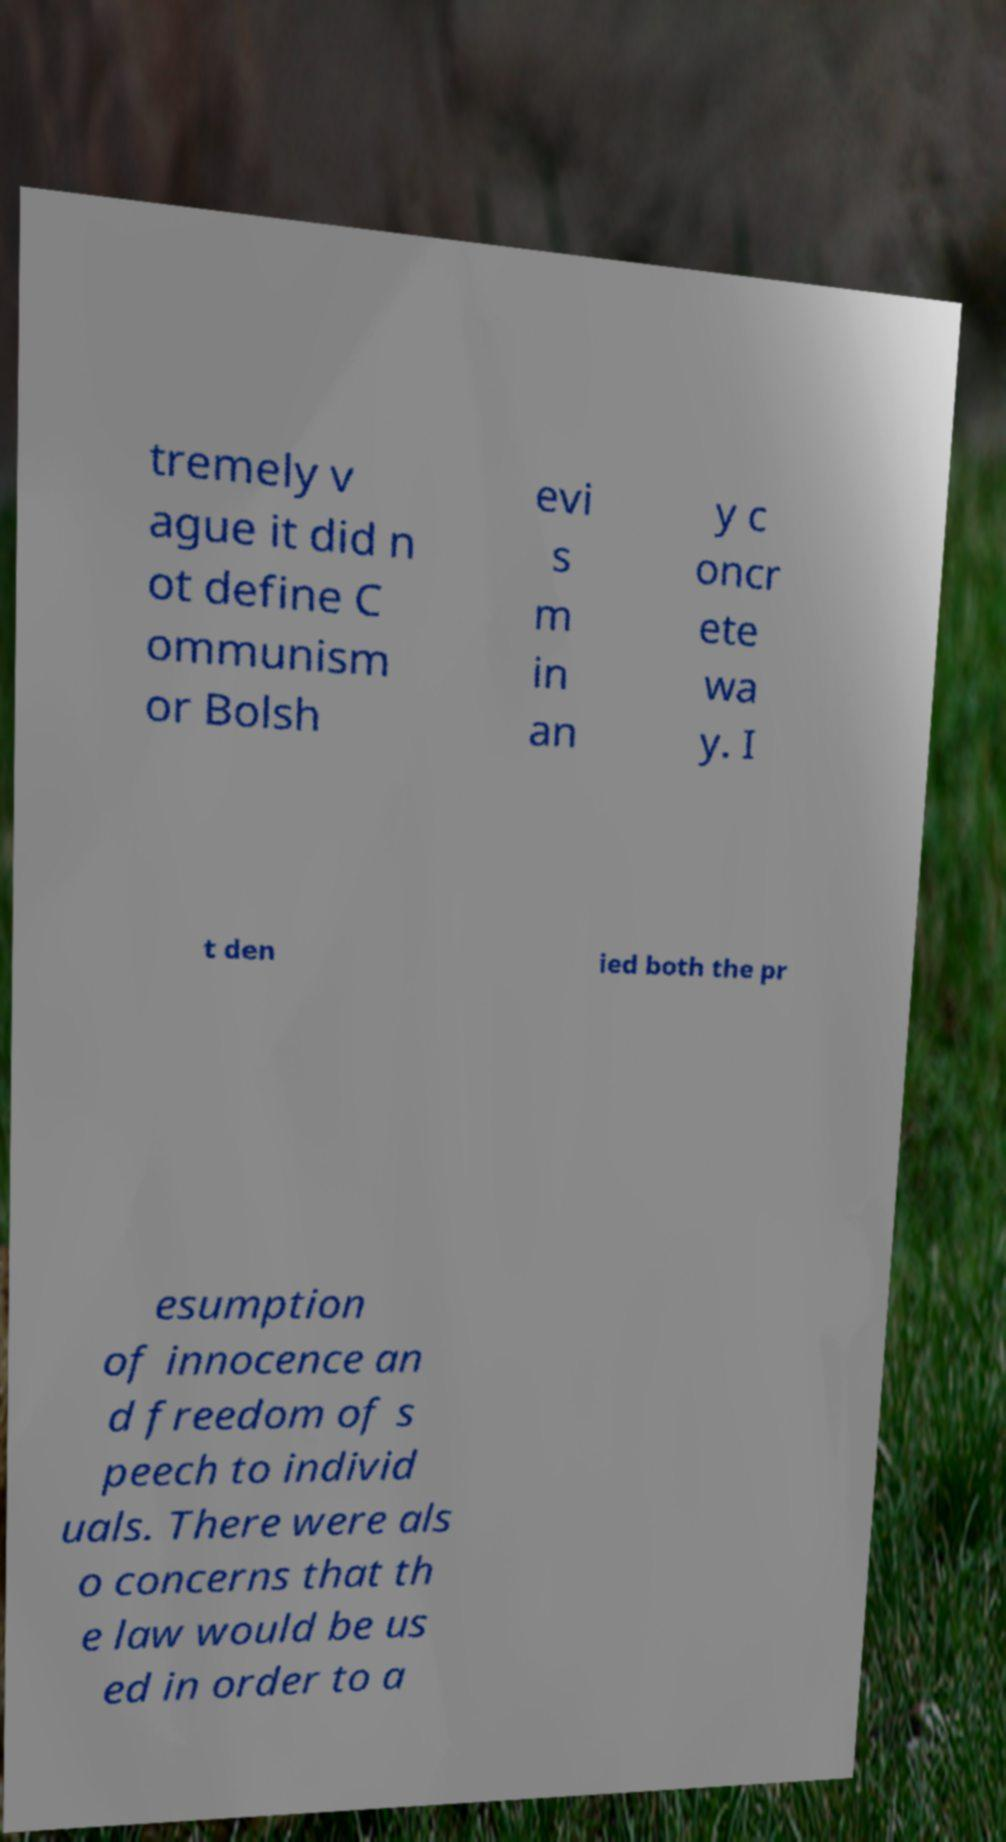What messages or text are displayed in this image? I need them in a readable, typed format. tremely v ague it did n ot define C ommunism or Bolsh evi s m in an y c oncr ete wa y. I t den ied both the pr esumption of innocence an d freedom of s peech to individ uals. There were als o concerns that th e law would be us ed in order to a 